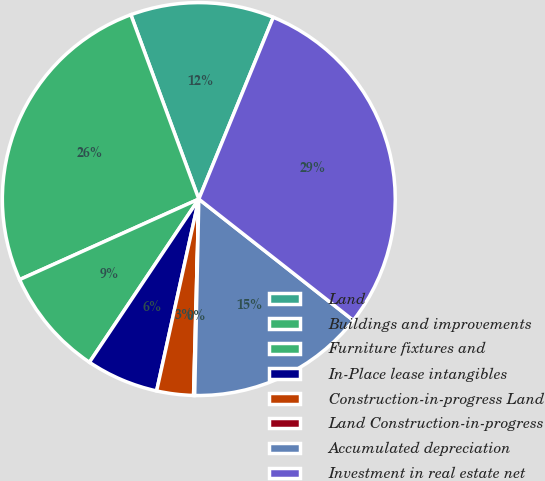Convert chart. <chart><loc_0><loc_0><loc_500><loc_500><pie_chart><fcel>Land<fcel>Buildings and improvements<fcel>Furniture fixtures and<fcel>In-Place lease intangibles<fcel>Construction-in-progress Land<fcel>Land Construction-in-progress<fcel>Accumulated depreciation<fcel>Investment in real estate net<nl><fcel>11.81%<fcel>26.1%<fcel>8.88%<fcel>5.95%<fcel>3.02%<fcel>0.09%<fcel>14.74%<fcel>29.4%<nl></chart> 